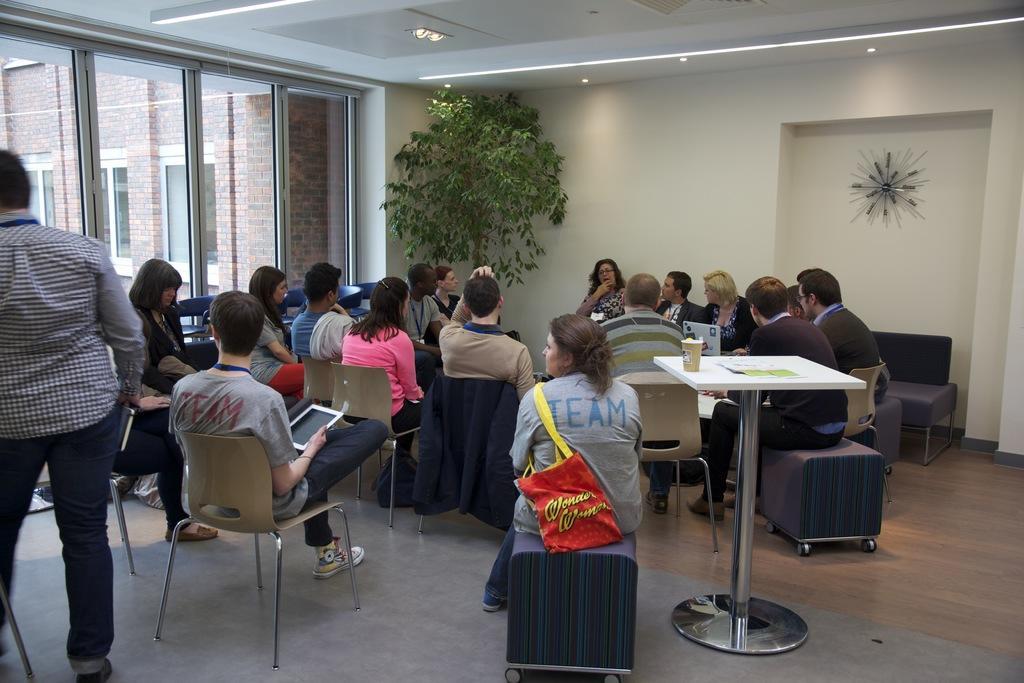In one or two sentences, can you explain what this image depicts? In this image we can see many people are sitting on the chairs. This is the tree, cup on the table, glass windows and building. 